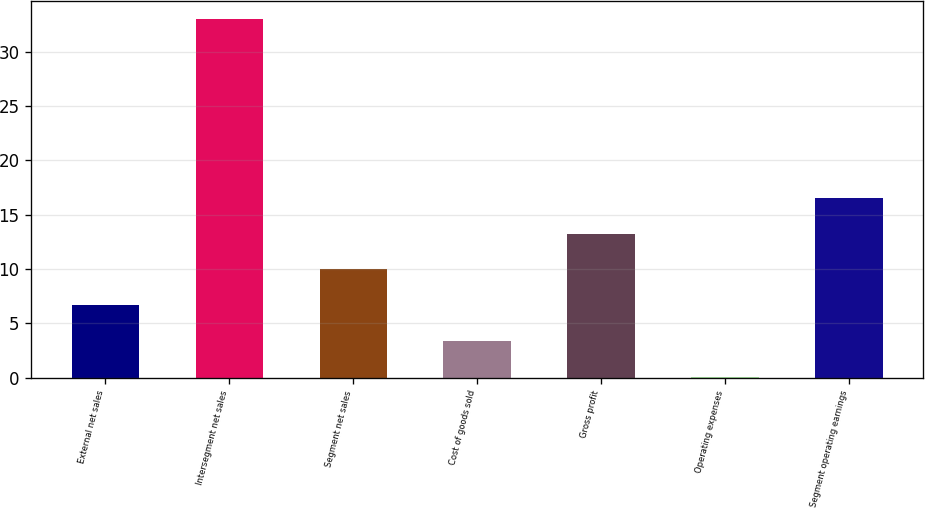<chart> <loc_0><loc_0><loc_500><loc_500><bar_chart><fcel>External net sales<fcel>Intersegment net sales<fcel>Segment net sales<fcel>Cost of goods sold<fcel>Gross profit<fcel>Operating expenses<fcel>Segment operating earnings<nl><fcel>6.68<fcel>33<fcel>9.97<fcel>3.39<fcel>13.26<fcel>0.1<fcel>16.55<nl></chart> 